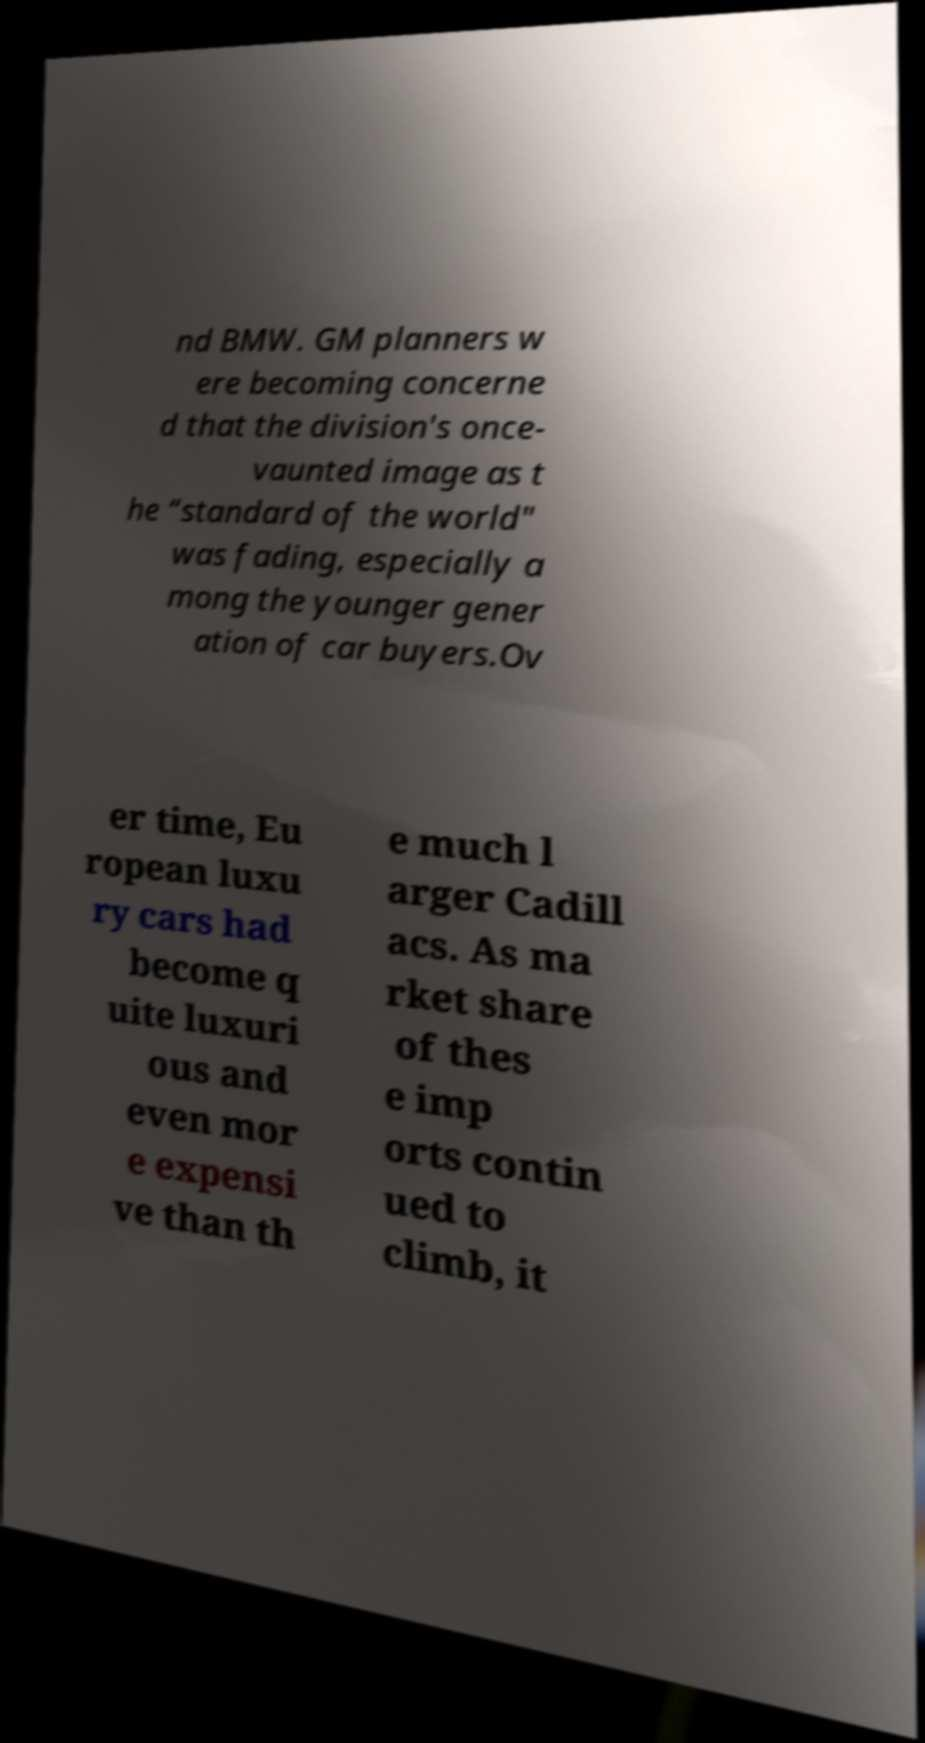Please read and relay the text visible in this image. What does it say? nd BMW. GM planners w ere becoming concerne d that the division's once- vaunted image as t he “standard of the world" was fading, especially a mong the younger gener ation of car buyers.Ov er time, Eu ropean luxu ry cars had become q uite luxuri ous and even mor e expensi ve than th e much l arger Cadill acs. As ma rket share of thes e imp orts contin ued to climb, it 